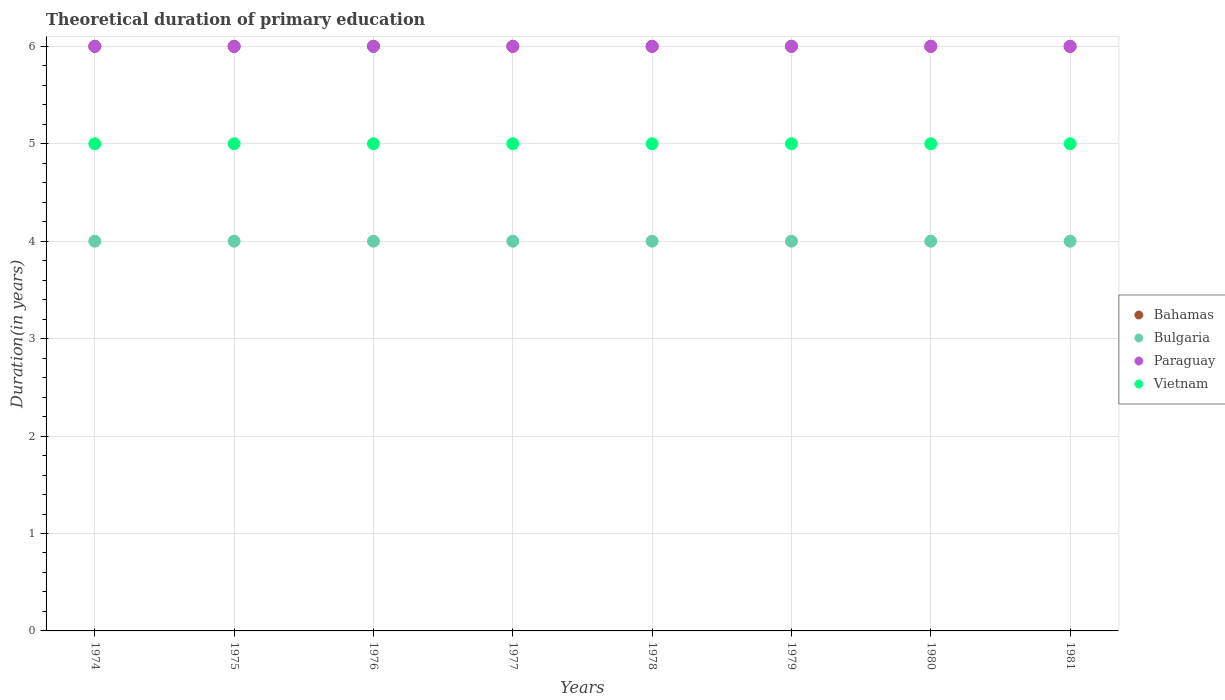How many different coloured dotlines are there?
Your answer should be compact. 4. What is the total theoretical duration of primary education in Bahamas in 1975?
Ensure brevity in your answer.  6. Across all years, what is the maximum total theoretical duration of primary education in Bulgaria?
Keep it short and to the point. 4. Across all years, what is the minimum total theoretical duration of primary education in Bahamas?
Provide a succinct answer. 6. In which year was the total theoretical duration of primary education in Paraguay maximum?
Provide a succinct answer. 1974. In which year was the total theoretical duration of primary education in Bulgaria minimum?
Offer a very short reply. 1974. What is the total total theoretical duration of primary education in Paraguay in the graph?
Keep it short and to the point. 48. What is the difference between the total theoretical duration of primary education in Vietnam in 1978 and that in 1981?
Offer a very short reply. 0. What is the difference between the total theoretical duration of primary education in Bulgaria in 1975 and the total theoretical duration of primary education in Bahamas in 1977?
Your response must be concise. -2. In the year 1979, what is the difference between the total theoretical duration of primary education in Paraguay and total theoretical duration of primary education in Vietnam?
Your answer should be compact. 1. In how many years, is the total theoretical duration of primary education in Bahamas greater than 3.2 years?
Ensure brevity in your answer.  8. What is the ratio of the total theoretical duration of primary education in Bulgaria in 1977 to that in 1980?
Offer a terse response. 1. Is the total theoretical duration of primary education in Bulgaria in 1974 less than that in 1975?
Offer a terse response. No. What is the difference between the highest and the second highest total theoretical duration of primary education in Bulgaria?
Your answer should be very brief. 0. In how many years, is the total theoretical duration of primary education in Bahamas greater than the average total theoretical duration of primary education in Bahamas taken over all years?
Ensure brevity in your answer.  0. Is the sum of the total theoretical duration of primary education in Bulgaria in 1974 and 1981 greater than the maximum total theoretical duration of primary education in Vietnam across all years?
Ensure brevity in your answer.  Yes. Is it the case that in every year, the sum of the total theoretical duration of primary education in Bahamas and total theoretical duration of primary education in Bulgaria  is greater than the sum of total theoretical duration of primary education in Vietnam and total theoretical duration of primary education in Paraguay?
Keep it short and to the point. No. Is the total theoretical duration of primary education in Vietnam strictly greater than the total theoretical duration of primary education in Bulgaria over the years?
Provide a succinct answer. Yes. How many years are there in the graph?
Your answer should be very brief. 8. What is the difference between two consecutive major ticks on the Y-axis?
Offer a very short reply. 1. Are the values on the major ticks of Y-axis written in scientific E-notation?
Your answer should be compact. No. Does the graph contain any zero values?
Make the answer very short. No. Does the graph contain grids?
Ensure brevity in your answer.  Yes. What is the title of the graph?
Offer a terse response. Theoretical duration of primary education. What is the label or title of the Y-axis?
Your response must be concise. Duration(in years). What is the Duration(in years) of Bulgaria in 1975?
Your answer should be compact. 4. What is the Duration(in years) in Paraguay in 1975?
Your answer should be compact. 6. What is the Duration(in years) in Vietnam in 1975?
Offer a terse response. 5. What is the Duration(in years) of Bulgaria in 1976?
Your response must be concise. 4. What is the Duration(in years) of Paraguay in 1976?
Provide a short and direct response. 6. What is the Duration(in years) of Bahamas in 1977?
Your answer should be compact. 6. What is the Duration(in years) of Bulgaria in 1977?
Keep it short and to the point. 4. What is the Duration(in years) in Vietnam in 1977?
Your answer should be very brief. 5. What is the Duration(in years) in Bahamas in 1978?
Your answer should be very brief. 6. What is the Duration(in years) of Vietnam in 1978?
Your response must be concise. 5. What is the Duration(in years) of Bahamas in 1979?
Offer a terse response. 6. What is the Duration(in years) in Bulgaria in 1979?
Provide a succinct answer. 4. What is the Duration(in years) of Vietnam in 1979?
Give a very brief answer. 5. What is the Duration(in years) of Bahamas in 1980?
Offer a terse response. 6. What is the Duration(in years) in Bulgaria in 1980?
Your answer should be very brief. 4. What is the Duration(in years) in Vietnam in 1980?
Provide a short and direct response. 5. What is the Duration(in years) in Paraguay in 1981?
Keep it short and to the point. 6. Across all years, what is the maximum Duration(in years) of Bulgaria?
Provide a short and direct response. 4. Across all years, what is the maximum Duration(in years) in Vietnam?
Provide a short and direct response. 5. Across all years, what is the minimum Duration(in years) of Bahamas?
Make the answer very short. 6. Across all years, what is the minimum Duration(in years) in Bulgaria?
Offer a very short reply. 4. Across all years, what is the minimum Duration(in years) of Paraguay?
Your answer should be compact. 6. Across all years, what is the minimum Duration(in years) in Vietnam?
Offer a terse response. 5. What is the total Duration(in years) in Bahamas in the graph?
Offer a terse response. 48. What is the total Duration(in years) in Paraguay in the graph?
Give a very brief answer. 48. What is the total Duration(in years) in Vietnam in the graph?
Keep it short and to the point. 40. What is the difference between the Duration(in years) in Bulgaria in 1974 and that in 1975?
Give a very brief answer. 0. What is the difference between the Duration(in years) in Paraguay in 1974 and that in 1975?
Offer a terse response. 0. What is the difference between the Duration(in years) in Vietnam in 1974 and that in 1975?
Keep it short and to the point. 0. What is the difference between the Duration(in years) of Bulgaria in 1974 and that in 1976?
Offer a terse response. 0. What is the difference between the Duration(in years) of Paraguay in 1974 and that in 1976?
Your answer should be compact. 0. What is the difference between the Duration(in years) of Bahamas in 1974 and that in 1977?
Make the answer very short. 0. What is the difference between the Duration(in years) in Vietnam in 1974 and that in 1977?
Provide a short and direct response. 0. What is the difference between the Duration(in years) of Bulgaria in 1974 and that in 1978?
Your response must be concise. 0. What is the difference between the Duration(in years) of Paraguay in 1974 and that in 1978?
Make the answer very short. 0. What is the difference between the Duration(in years) of Vietnam in 1974 and that in 1978?
Provide a succinct answer. 0. What is the difference between the Duration(in years) in Bahamas in 1974 and that in 1980?
Offer a very short reply. 0. What is the difference between the Duration(in years) in Paraguay in 1974 and that in 1981?
Provide a short and direct response. 0. What is the difference between the Duration(in years) of Paraguay in 1975 and that in 1976?
Your answer should be compact. 0. What is the difference between the Duration(in years) in Vietnam in 1975 and that in 1976?
Keep it short and to the point. 0. What is the difference between the Duration(in years) in Bulgaria in 1975 and that in 1977?
Ensure brevity in your answer.  0. What is the difference between the Duration(in years) of Vietnam in 1975 and that in 1977?
Make the answer very short. 0. What is the difference between the Duration(in years) of Vietnam in 1975 and that in 1978?
Offer a very short reply. 0. What is the difference between the Duration(in years) of Paraguay in 1975 and that in 1979?
Your response must be concise. 0. What is the difference between the Duration(in years) of Paraguay in 1975 and that in 1980?
Your answer should be very brief. 0. What is the difference between the Duration(in years) in Vietnam in 1975 and that in 1980?
Keep it short and to the point. 0. What is the difference between the Duration(in years) of Paraguay in 1975 and that in 1981?
Provide a short and direct response. 0. What is the difference between the Duration(in years) of Vietnam in 1975 and that in 1981?
Provide a succinct answer. 0. What is the difference between the Duration(in years) in Bulgaria in 1976 and that in 1977?
Offer a terse response. 0. What is the difference between the Duration(in years) in Paraguay in 1976 and that in 1977?
Ensure brevity in your answer.  0. What is the difference between the Duration(in years) in Vietnam in 1976 and that in 1977?
Your answer should be compact. 0. What is the difference between the Duration(in years) in Bulgaria in 1976 and that in 1978?
Your response must be concise. 0. What is the difference between the Duration(in years) in Vietnam in 1976 and that in 1978?
Make the answer very short. 0. What is the difference between the Duration(in years) of Bulgaria in 1976 and that in 1979?
Ensure brevity in your answer.  0. What is the difference between the Duration(in years) of Vietnam in 1976 and that in 1979?
Your answer should be very brief. 0. What is the difference between the Duration(in years) of Bahamas in 1976 and that in 1980?
Provide a short and direct response. 0. What is the difference between the Duration(in years) of Paraguay in 1976 and that in 1980?
Your answer should be compact. 0. What is the difference between the Duration(in years) of Bulgaria in 1976 and that in 1981?
Give a very brief answer. 0. What is the difference between the Duration(in years) of Paraguay in 1976 and that in 1981?
Your answer should be compact. 0. What is the difference between the Duration(in years) of Vietnam in 1976 and that in 1981?
Ensure brevity in your answer.  0. What is the difference between the Duration(in years) in Bulgaria in 1977 and that in 1978?
Provide a short and direct response. 0. What is the difference between the Duration(in years) in Paraguay in 1977 and that in 1978?
Offer a very short reply. 0. What is the difference between the Duration(in years) of Bulgaria in 1977 and that in 1979?
Provide a short and direct response. 0. What is the difference between the Duration(in years) in Paraguay in 1977 and that in 1979?
Your answer should be very brief. 0. What is the difference between the Duration(in years) in Vietnam in 1977 and that in 1980?
Provide a succinct answer. 0. What is the difference between the Duration(in years) in Bahamas in 1977 and that in 1981?
Provide a short and direct response. 0. What is the difference between the Duration(in years) of Paraguay in 1977 and that in 1981?
Your answer should be compact. 0. What is the difference between the Duration(in years) of Paraguay in 1978 and that in 1980?
Offer a terse response. 0. What is the difference between the Duration(in years) in Vietnam in 1978 and that in 1980?
Your answer should be very brief. 0. What is the difference between the Duration(in years) of Vietnam in 1978 and that in 1981?
Keep it short and to the point. 0. What is the difference between the Duration(in years) in Paraguay in 1979 and that in 1980?
Offer a very short reply. 0. What is the difference between the Duration(in years) in Bahamas in 1979 and that in 1981?
Offer a very short reply. 0. What is the difference between the Duration(in years) of Bulgaria in 1979 and that in 1981?
Make the answer very short. 0. What is the difference between the Duration(in years) of Vietnam in 1979 and that in 1981?
Your answer should be compact. 0. What is the difference between the Duration(in years) of Bulgaria in 1980 and that in 1981?
Your response must be concise. 0. What is the difference between the Duration(in years) in Bahamas in 1974 and the Duration(in years) in Paraguay in 1975?
Keep it short and to the point. 0. What is the difference between the Duration(in years) of Bahamas in 1974 and the Duration(in years) of Vietnam in 1975?
Offer a terse response. 1. What is the difference between the Duration(in years) of Bulgaria in 1974 and the Duration(in years) of Paraguay in 1975?
Your answer should be very brief. -2. What is the difference between the Duration(in years) in Bulgaria in 1974 and the Duration(in years) in Vietnam in 1975?
Offer a very short reply. -1. What is the difference between the Duration(in years) in Bahamas in 1974 and the Duration(in years) in Paraguay in 1976?
Offer a very short reply. 0. What is the difference between the Duration(in years) of Bulgaria in 1974 and the Duration(in years) of Paraguay in 1976?
Keep it short and to the point. -2. What is the difference between the Duration(in years) in Bulgaria in 1974 and the Duration(in years) in Vietnam in 1976?
Offer a terse response. -1. What is the difference between the Duration(in years) in Bahamas in 1974 and the Duration(in years) in Bulgaria in 1977?
Your response must be concise. 2. What is the difference between the Duration(in years) of Bahamas in 1974 and the Duration(in years) of Paraguay in 1977?
Give a very brief answer. 0. What is the difference between the Duration(in years) of Bulgaria in 1974 and the Duration(in years) of Vietnam in 1977?
Ensure brevity in your answer.  -1. What is the difference between the Duration(in years) of Paraguay in 1974 and the Duration(in years) of Vietnam in 1977?
Offer a very short reply. 1. What is the difference between the Duration(in years) of Bahamas in 1974 and the Duration(in years) of Bulgaria in 1978?
Provide a succinct answer. 2. What is the difference between the Duration(in years) of Bahamas in 1974 and the Duration(in years) of Paraguay in 1978?
Ensure brevity in your answer.  0. What is the difference between the Duration(in years) of Bulgaria in 1974 and the Duration(in years) of Paraguay in 1978?
Provide a short and direct response. -2. What is the difference between the Duration(in years) of Bahamas in 1974 and the Duration(in years) of Bulgaria in 1979?
Offer a very short reply. 2. What is the difference between the Duration(in years) of Bulgaria in 1974 and the Duration(in years) of Vietnam in 1979?
Your answer should be compact. -1. What is the difference between the Duration(in years) in Bahamas in 1974 and the Duration(in years) in Paraguay in 1980?
Your response must be concise. 0. What is the difference between the Duration(in years) in Bulgaria in 1974 and the Duration(in years) in Vietnam in 1980?
Provide a short and direct response. -1. What is the difference between the Duration(in years) in Bahamas in 1974 and the Duration(in years) in Paraguay in 1981?
Keep it short and to the point. 0. What is the difference between the Duration(in years) of Bahamas in 1974 and the Duration(in years) of Vietnam in 1981?
Keep it short and to the point. 1. What is the difference between the Duration(in years) of Bulgaria in 1974 and the Duration(in years) of Vietnam in 1981?
Keep it short and to the point. -1. What is the difference between the Duration(in years) of Paraguay in 1974 and the Duration(in years) of Vietnam in 1981?
Offer a terse response. 1. What is the difference between the Duration(in years) of Bahamas in 1975 and the Duration(in years) of Paraguay in 1976?
Provide a short and direct response. 0. What is the difference between the Duration(in years) in Bahamas in 1975 and the Duration(in years) in Vietnam in 1976?
Give a very brief answer. 1. What is the difference between the Duration(in years) of Paraguay in 1975 and the Duration(in years) of Vietnam in 1976?
Provide a succinct answer. 1. What is the difference between the Duration(in years) in Bahamas in 1975 and the Duration(in years) in Bulgaria in 1977?
Ensure brevity in your answer.  2. What is the difference between the Duration(in years) of Bulgaria in 1975 and the Duration(in years) of Vietnam in 1977?
Provide a short and direct response. -1. What is the difference between the Duration(in years) of Paraguay in 1975 and the Duration(in years) of Vietnam in 1977?
Your response must be concise. 1. What is the difference between the Duration(in years) in Bahamas in 1975 and the Duration(in years) in Paraguay in 1978?
Your response must be concise. 0. What is the difference between the Duration(in years) in Bahamas in 1975 and the Duration(in years) in Vietnam in 1978?
Ensure brevity in your answer.  1. What is the difference between the Duration(in years) in Bulgaria in 1975 and the Duration(in years) in Paraguay in 1978?
Offer a terse response. -2. What is the difference between the Duration(in years) of Bahamas in 1975 and the Duration(in years) of Bulgaria in 1979?
Make the answer very short. 2. What is the difference between the Duration(in years) of Bahamas in 1975 and the Duration(in years) of Paraguay in 1979?
Keep it short and to the point. 0. What is the difference between the Duration(in years) in Bahamas in 1975 and the Duration(in years) in Vietnam in 1979?
Your response must be concise. 1. What is the difference between the Duration(in years) of Bulgaria in 1975 and the Duration(in years) of Paraguay in 1979?
Your answer should be very brief. -2. What is the difference between the Duration(in years) in Bulgaria in 1975 and the Duration(in years) in Vietnam in 1979?
Your answer should be compact. -1. What is the difference between the Duration(in years) in Paraguay in 1975 and the Duration(in years) in Vietnam in 1979?
Offer a very short reply. 1. What is the difference between the Duration(in years) in Bulgaria in 1975 and the Duration(in years) in Paraguay in 1980?
Keep it short and to the point. -2. What is the difference between the Duration(in years) in Paraguay in 1975 and the Duration(in years) in Vietnam in 1980?
Offer a terse response. 1. What is the difference between the Duration(in years) in Bahamas in 1975 and the Duration(in years) in Bulgaria in 1981?
Your response must be concise. 2. What is the difference between the Duration(in years) of Bahamas in 1975 and the Duration(in years) of Paraguay in 1981?
Offer a terse response. 0. What is the difference between the Duration(in years) of Bahamas in 1975 and the Duration(in years) of Vietnam in 1981?
Offer a terse response. 1. What is the difference between the Duration(in years) in Bulgaria in 1975 and the Duration(in years) in Paraguay in 1981?
Your answer should be compact. -2. What is the difference between the Duration(in years) of Paraguay in 1975 and the Duration(in years) of Vietnam in 1981?
Your response must be concise. 1. What is the difference between the Duration(in years) in Bahamas in 1976 and the Duration(in years) in Bulgaria in 1977?
Offer a terse response. 2. What is the difference between the Duration(in years) of Bulgaria in 1976 and the Duration(in years) of Paraguay in 1977?
Your response must be concise. -2. What is the difference between the Duration(in years) in Bahamas in 1976 and the Duration(in years) in Paraguay in 1978?
Provide a short and direct response. 0. What is the difference between the Duration(in years) in Bulgaria in 1976 and the Duration(in years) in Paraguay in 1978?
Provide a short and direct response. -2. What is the difference between the Duration(in years) of Bulgaria in 1976 and the Duration(in years) of Vietnam in 1978?
Your response must be concise. -1. What is the difference between the Duration(in years) in Bahamas in 1976 and the Duration(in years) in Paraguay in 1979?
Your response must be concise. 0. What is the difference between the Duration(in years) in Bahamas in 1976 and the Duration(in years) in Vietnam in 1979?
Keep it short and to the point. 1. What is the difference between the Duration(in years) of Bahamas in 1976 and the Duration(in years) of Paraguay in 1980?
Give a very brief answer. 0. What is the difference between the Duration(in years) of Bulgaria in 1976 and the Duration(in years) of Paraguay in 1980?
Offer a terse response. -2. What is the difference between the Duration(in years) of Bulgaria in 1976 and the Duration(in years) of Vietnam in 1980?
Your response must be concise. -1. What is the difference between the Duration(in years) of Bahamas in 1976 and the Duration(in years) of Bulgaria in 1981?
Your answer should be compact. 2. What is the difference between the Duration(in years) in Bulgaria in 1976 and the Duration(in years) in Paraguay in 1981?
Offer a very short reply. -2. What is the difference between the Duration(in years) of Paraguay in 1976 and the Duration(in years) of Vietnam in 1981?
Make the answer very short. 1. What is the difference between the Duration(in years) in Bahamas in 1977 and the Duration(in years) in Bulgaria in 1978?
Ensure brevity in your answer.  2. What is the difference between the Duration(in years) in Paraguay in 1977 and the Duration(in years) in Vietnam in 1978?
Provide a short and direct response. 1. What is the difference between the Duration(in years) in Bahamas in 1977 and the Duration(in years) in Bulgaria in 1979?
Offer a terse response. 2. What is the difference between the Duration(in years) of Bahamas in 1977 and the Duration(in years) of Vietnam in 1979?
Offer a terse response. 1. What is the difference between the Duration(in years) of Bulgaria in 1977 and the Duration(in years) of Paraguay in 1979?
Offer a very short reply. -2. What is the difference between the Duration(in years) of Paraguay in 1977 and the Duration(in years) of Vietnam in 1979?
Your answer should be compact. 1. What is the difference between the Duration(in years) of Bahamas in 1977 and the Duration(in years) of Vietnam in 1980?
Make the answer very short. 1. What is the difference between the Duration(in years) in Bulgaria in 1977 and the Duration(in years) in Vietnam in 1980?
Offer a terse response. -1. What is the difference between the Duration(in years) in Paraguay in 1977 and the Duration(in years) in Vietnam in 1980?
Ensure brevity in your answer.  1. What is the difference between the Duration(in years) of Bahamas in 1977 and the Duration(in years) of Bulgaria in 1981?
Offer a terse response. 2. What is the difference between the Duration(in years) in Bahamas in 1977 and the Duration(in years) in Vietnam in 1981?
Your answer should be compact. 1. What is the difference between the Duration(in years) of Bulgaria in 1977 and the Duration(in years) of Vietnam in 1981?
Your answer should be compact. -1. What is the difference between the Duration(in years) in Bahamas in 1978 and the Duration(in years) in Vietnam in 1979?
Offer a very short reply. 1. What is the difference between the Duration(in years) of Bulgaria in 1978 and the Duration(in years) of Paraguay in 1979?
Your answer should be compact. -2. What is the difference between the Duration(in years) in Bulgaria in 1978 and the Duration(in years) in Vietnam in 1979?
Your answer should be very brief. -1. What is the difference between the Duration(in years) of Bahamas in 1978 and the Duration(in years) of Vietnam in 1980?
Make the answer very short. 1. What is the difference between the Duration(in years) of Bulgaria in 1978 and the Duration(in years) of Paraguay in 1980?
Offer a terse response. -2. What is the difference between the Duration(in years) in Bulgaria in 1978 and the Duration(in years) in Vietnam in 1980?
Offer a very short reply. -1. What is the difference between the Duration(in years) in Bahamas in 1978 and the Duration(in years) in Bulgaria in 1981?
Provide a succinct answer. 2. What is the difference between the Duration(in years) in Bulgaria in 1978 and the Duration(in years) in Paraguay in 1981?
Give a very brief answer. -2. What is the difference between the Duration(in years) in Bulgaria in 1978 and the Duration(in years) in Vietnam in 1981?
Your response must be concise. -1. What is the difference between the Duration(in years) of Paraguay in 1978 and the Duration(in years) of Vietnam in 1981?
Provide a short and direct response. 1. What is the difference between the Duration(in years) in Bahamas in 1979 and the Duration(in years) in Bulgaria in 1980?
Offer a terse response. 2. What is the difference between the Duration(in years) of Bahamas in 1979 and the Duration(in years) of Paraguay in 1980?
Make the answer very short. 0. What is the difference between the Duration(in years) in Bulgaria in 1979 and the Duration(in years) in Paraguay in 1980?
Your answer should be compact. -2. What is the difference between the Duration(in years) of Paraguay in 1979 and the Duration(in years) of Vietnam in 1980?
Your answer should be compact. 1. What is the difference between the Duration(in years) of Bahamas in 1979 and the Duration(in years) of Paraguay in 1981?
Offer a very short reply. 0. What is the difference between the Duration(in years) of Paraguay in 1979 and the Duration(in years) of Vietnam in 1981?
Ensure brevity in your answer.  1. What is the difference between the Duration(in years) of Bahamas in 1980 and the Duration(in years) of Bulgaria in 1981?
Your answer should be compact. 2. What is the difference between the Duration(in years) of Bulgaria in 1980 and the Duration(in years) of Paraguay in 1981?
Provide a succinct answer. -2. What is the average Duration(in years) of Bulgaria per year?
Keep it short and to the point. 4. What is the average Duration(in years) in Paraguay per year?
Your answer should be very brief. 6. In the year 1974, what is the difference between the Duration(in years) in Bahamas and Duration(in years) in Paraguay?
Give a very brief answer. 0. In the year 1975, what is the difference between the Duration(in years) in Bahamas and Duration(in years) in Bulgaria?
Keep it short and to the point. 2. In the year 1975, what is the difference between the Duration(in years) of Bulgaria and Duration(in years) of Paraguay?
Provide a short and direct response. -2. In the year 1975, what is the difference between the Duration(in years) of Bulgaria and Duration(in years) of Vietnam?
Your answer should be very brief. -1. In the year 1975, what is the difference between the Duration(in years) in Paraguay and Duration(in years) in Vietnam?
Ensure brevity in your answer.  1. In the year 1976, what is the difference between the Duration(in years) of Bahamas and Duration(in years) of Bulgaria?
Keep it short and to the point. 2. In the year 1976, what is the difference between the Duration(in years) in Bahamas and Duration(in years) in Paraguay?
Provide a short and direct response. 0. In the year 1976, what is the difference between the Duration(in years) in Bahamas and Duration(in years) in Vietnam?
Your answer should be very brief. 1. In the year 1977, what is the difference between the Duration(in years) of Bahamas and Duration(in years) of Bulgaria?
Provide a short and direct response. 2. In the year 1977, what is the difference between the Duration(in years) of Bahamas and Duration(in years) of Vietnam?
Your answer should be very brief. 1. In the year 1977, what is the difference between the Duration(in years) in Bulgaria and Duration(in years) in Vietnam?
Your response must be concise. -1. In the year 1977, what is the difference between the Duration(in years) of Paraguay and Duration(in years) of Vietnam?
Offer a terse response. 1. In the year 1978, what is the difference between the Duration(in years) in Bahamas and Duration(in years) in Paraguay?
Offer a terse response. 0. In the year 1978, what is the difference between the Duration(in years) in Bulgaria and Duration(in years) in Paraguay?
Offer a terse response. -2. In the year 1978, what is the difference between the Duration(in years) in Paraguay and Duration(in years) in Vietnam?
Give a very brief answer. 1. In the year 1979, what is the difference between the Duration(in years) in Bahamas and Duration(in years) in Bulgaria?
Your answer should be very brief. 2. In the year 1979, what is the difference between the Duration(in years) in Bahamas and Duration(in years) in Paraguay?
Ensure brevity in your answer.  0. In the year 1979, what is the difference between the Duration(in years) in Bahamas and Duration(in years) in Vietnam?
Offer a very short reply. 1. In the year 1979, what is the difference between the Duration(in years) of Bulgaria and Duration(in years) of Vietnam?
Your answer should be very brief. -1. In the year 1979, what is the difference between the Duration(in years) in Paraguay and Duration(in years) in Vietnam?
Your answer should be very brief. 1. In the year 1980, what is the difference between the Duration(in years) in Bahamas and Duration(in years) in Bulgaria?
Your response must be concise. 2. In the year 1980, what is the difference between the Duration(in years) of Bahamas and Duration(in years) of Vietnam?
Offer a very short reply. 1. In the year 1980, what is the difference between the Duration(in years) of Bulgaria and Duration(in years) of Paraguay?
Offer a terse response. -2. In the year 1980, what is the difference between the Duration(in years) in Bulgaria and Duration(in years) in Vietnam?
Give a very brief answer. -1. In the year 1980, what is the difference between the Duration(in years) of Paraguay and Duration(in years) of Vietnam?
Offer a very short reply. 1. In the year 1981, what is the difference between the Duration(in years) of Bahamas and Duration(in years) of Bulgaria?
Ensure brevity in your answer.  2. In the year 1981, what is the difference between the Duration(in years) in Bahamas and Duration(in years) in Paraguay?
Make the answer very short. 0. In the year 1981, what is the difference between the Duration(in years) of Bulgaria and Duration(in years) of Paraguay?
Your answer should be very brief. -2. In the year 1981, what is the difference between the Duration(in years) of Paraguay and Duration(in years) of Vietnam?
Ensure brevity in your answer.  1. What is the ratio of the Duration(in years) of Paraguay in 1974 to that in 1976?
Provide a short and direct response. 1. What is the ratio of the Duration(in years) of Vietnam in 1974 to that in 1976?
Your response must be concise. 1. What is the ratio of the Duration(in years) of Bahamas in 1974 to that in 1977?
Make the answer very short. 1. What is the ratio of the Duration(in years) in Paraguay in 1974 to that in 1977?
Your response must be concise. 1. What is the ratio of the Duration(in years) in Vietnam in 1974 to that in 1977?
Give a very brief answer. 1. What is the ratio of the Duration(in years) of Bulgaria in 1974 to that in 1978?
Provide a short and direct response. 1. What is the ratio of the Duration(in years) in Vietnam in 1974 to that in 1980?
Ensure brevity in your answer.  1. What is the ratio of the Duration(in years) in Bahamas in 1974 to that in 1981?
Ensure brevity in your answer.  1. What is the ratio of the Duration(in years) in Vietnam in 1974 to that in 1981?
Ensure brevity in your answer.  1. What is the ratio of the Duration(in years) in Vietnam in 1975 to that in 1976?
Provide a succinct answer. 1. What is the ratio of the Duration(in years) in Paraguay in 1975 to that in 1977?
Ensure brevity in your answer.  1. What is the ratio of the Duration(in years) in Vietnam in 1975 to that in 1978?
Your answer should be compact. 1. What is the ratio of the Duration(in years) of Bahamas in 1975 to that in 1979?
Your answer should be very brief. 1. What is the ratio of the Duration(in years) of Bahamas in 1975 to that in 1980?
Give a very brief answer. 1. What is the ratio of the Duration(in years) in Paraguay in 1975 to that in 1980?
Your response must be concise. 1. What is the ratio of the Duration(in years) of Vietnam in 1975 to that in 1980?
Provide a succinct answer. 1. What is the ratio of the Duration(in years) in Bahamas in 1975 to that in 1981?
Your response must be concise. 1. What is the ratio of the Duration(in years) of Vietnam in 1975 to that in 1981?
Offer a very short reply. 1. What is the ratio of the Duration(in years) of Vietnam in 1976 to that in 1977?
Ensure brevity in your answer.  1. What is the ratio of the Duration(in years) in Vietnam in 1976 to that in 1978?
Ensure brevity in your answer.  1. What is the ratio of the Duration(in years) in Paraguay in 1976 to that in 1979?
Provide a succinct answer. 1. What is the ratio of the Duration(in years) of Vietnam in 1976 to that in 1979?
Provide a short and direct response. 1. What is the ratio of the Duration(in years) in Bulgaria in 1976 to that in 1980?
Your response must be concise. 1. What is the ratio of the Duration(in years) of Paraguay in 1976 to that in 1980?
Provide a succinct answer. 1. What is the ratio of the Duration(in years) of Vietnam in 1976 to that in 1980?
Your response must be concise. 1. What is the ratio of the Duration(in years) in Paraguay in 1976 to that in 1981?
Give a very brief answer. 1. What is the ratio of the Duration(in years) of Vietnam in 1976 to that in 1981?
Your answer should be compact. 1. What is the ratio of the Duration(in years) of Bahamas in 1977 to that in 1978?
Provide a succinct answer. 1. What is the ratio of the Duration(in years) of Vietnam in 1977 to that in 1978?
Ensure brevity in your answer.  1. What is the ratio of the Duration(in years) of Bahamas in 1977 to that in 1979?
Ensure brevity in your answer.  1. What is the ratio of the Duration(in years) in Vietnam in 1977 to that in 1979?
Make the answer very short. 1. What is the ratio of the Duration(in years) in Bahamas in 1977 to that in 1980?
Give a very brief answer. 1. What is the ratio of the Duration(in years) in Vietnam in 1977 to that in 1980?
Your answer should be compact. 1. What is the ratio of the Duration(in years) of Vietnam in 1977 to that in 1981?
Your answer should be compact. 1. What is the ratio of the Duration(in years) of Bahamas in 1978 to that in 1979?
Make the answer very short. 1. What is the ratio of the Duration(in years) of Bulgaria in 1978 to that in 1979?
Offer a terse response. 1. What is the ratio of the Duration(in years) in Vietnam in 1978 to that in 1979?
Keep it short and to the point. 1. What is the ratio of the Duration(in years) of Bulgaria in 1978 to that in 1980?
Give a very brief answer. 1. What is the ratio of the Duration(in years) of Bahamas in 1978 to that in 1981?
Keep it short and to the point. 1. What is the ratio of the Duration(in years) of Bahamas in 1979 to that in 1980?
Your answer should be very brief. 1. What is the ratio of the Duration(in years) in Vietnam in 1979 to that in 1980?
Provide a short and direct response. 1. What is the ratio of the Duration(in years) of Paraguay in 1979 to that in 1981?
Provide a succinct answer. 1. What is the ratio of the Duration(in years) in Vietnam in 1979 to that in 1981?
Offer a very short reply. 1. What is the ratio of the Duration(in years) of Bulgaria in 1980 to that in 1981?
Offer a very short reply. 1. What is the ratio of the Duration(in years) of Paraguay in 1980 to that in 1981?
Your answer should be compact. 1. What is the ratio of the Duration(in years) in Vietnam in 1980 to that in 1981?
Give a very brief answer. 1. What is the difference between the highest and the second highest Duration(in years) in Bahamas?
Provide a succinct answer. 0. What is the difference between the highest and the second highest Duration(in years) of Bulgaria?
Your answer should be very brief. 0. What is the difference between the highest and the second highest Duration(in years) of Paraguay?
Make the answer very short. 0. What is the difference between the highest and the second highest Duration(in years) in Vietnam?
Offer a terse response. 0. What is the difference between the highest and the lowest Duration(in years) in Bahamas?
Provide a short and direct response. 0. What is the difference between the highest and the lowest Duration(in years) in Bulgaria?
Your response must be concise. 0. What is the difference between the highest and the lowest Duration(in years) of Vietnam?
Your answer should be very brief. 0. 